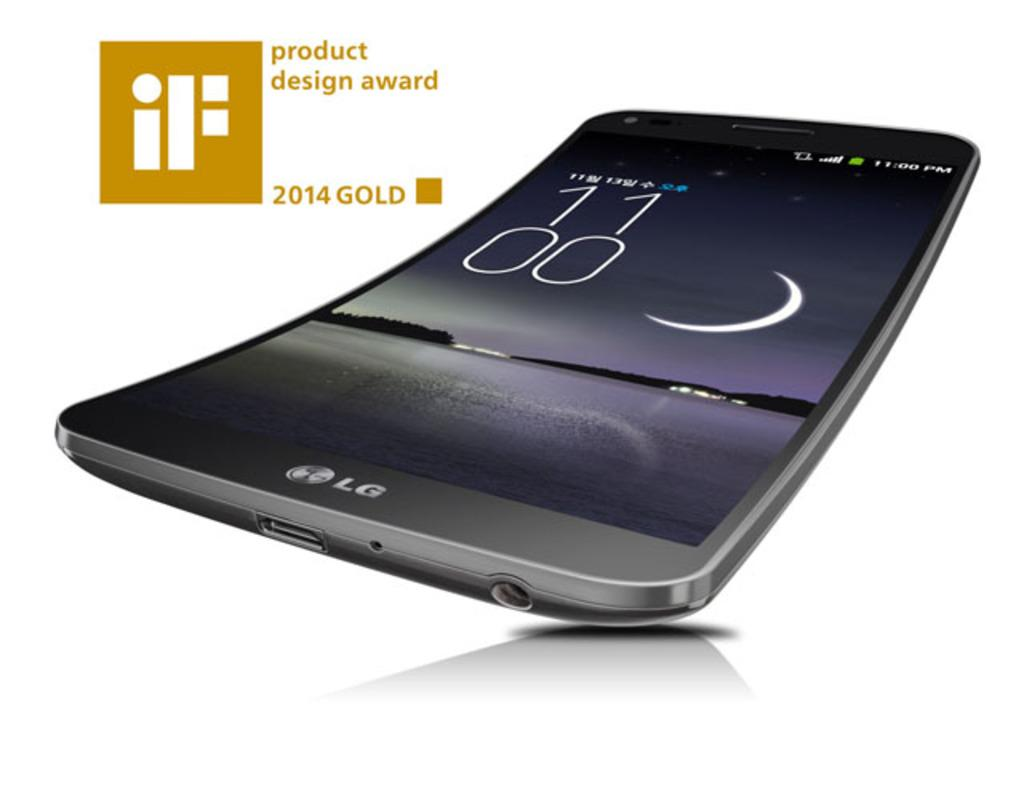Provide a one-sentence caption for the provided image. An LG phone is the recipient of the iF product design award. 